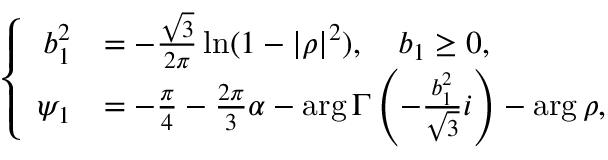<formula> <loc_0><loc_0><loc_500><loc_500>\left \{ \begin{array} { r l } { b _ { 1 } ^ { 2 } } & { = - \frac { \sqrt { 3 } } { 2 \pi } \ln ( 1 - \left | \rho \right | ^ { 2 } ) , \quad b _ { 1 } \geq 0 , } \\ { \psi _ { 1 } } & { = - \frac { \pi } { 4 } - \frac { 2 \pi } { 3 } \alpha - \arg \Gamma \left ( - \frac { b _ { 1 } ^ { 2 } } { \sqrt { 3 } } i \right ) - \arg \rho , } \end{array}</formula> 